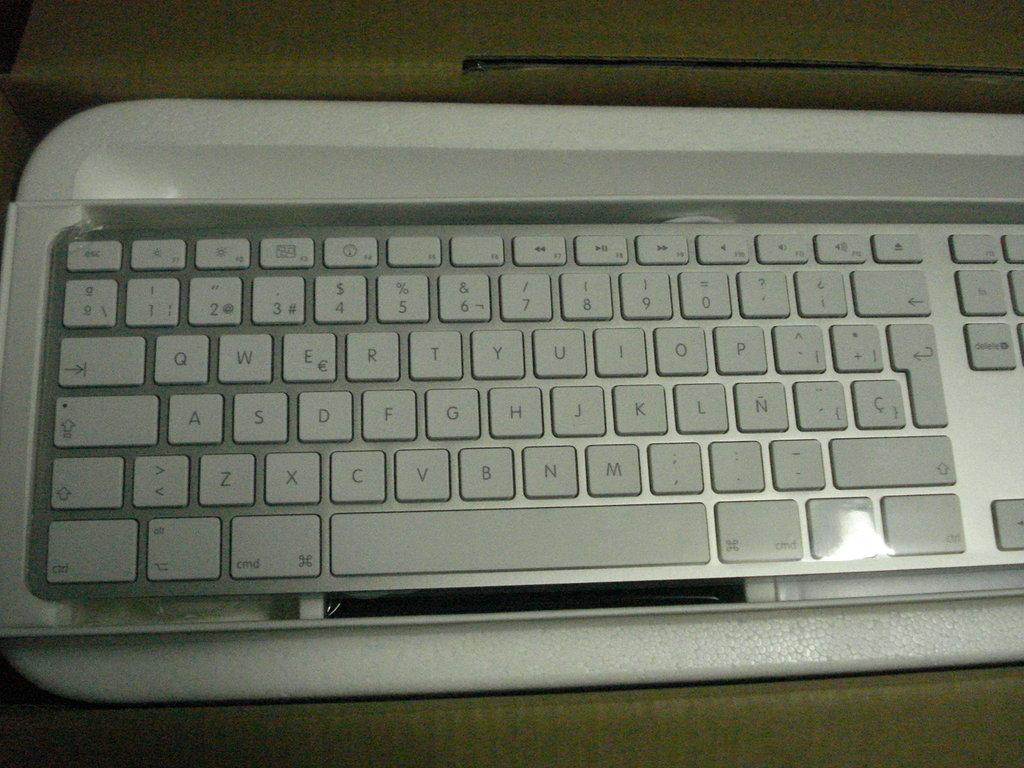What key is next to the q?
Offer a very short reply. W. 